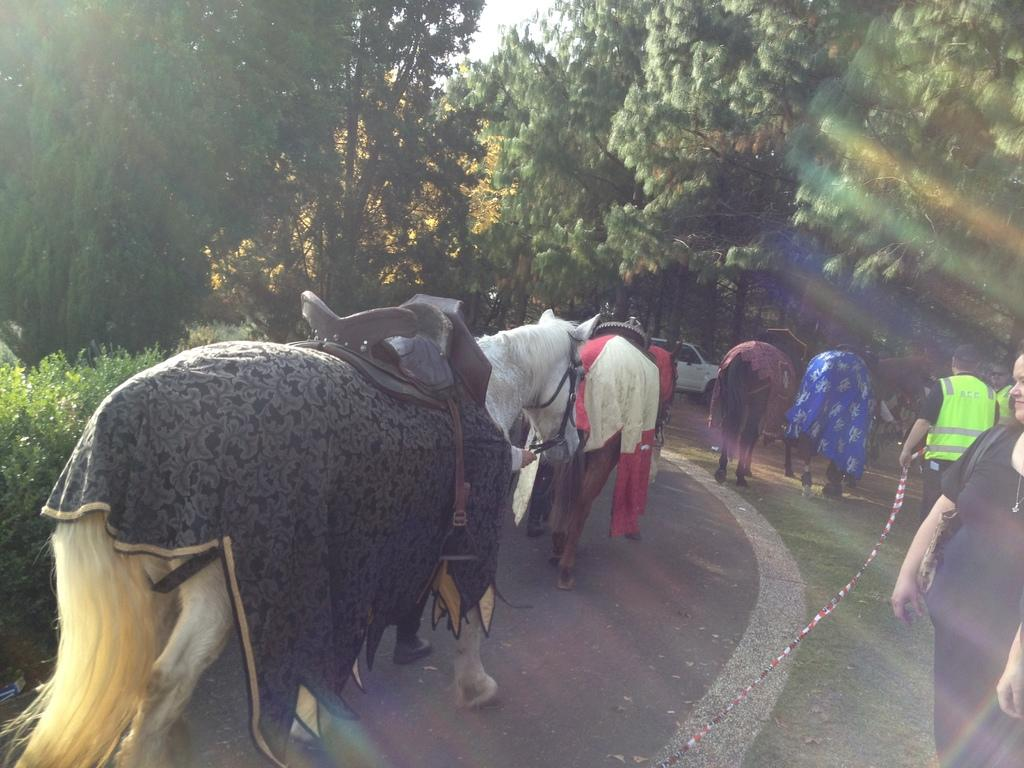How many people are in the image? There are people in the image, but the exact number is not specified. What is the man holding in the image? The man is holding a tape in the image. What animals are present in the image? There are horses in the image. What type of pathway is visible in the image? There is a road in the image. What type of vegetation is present in the image? There are plants in the image. What can be seen in the background of the image? There are trees, a car, and the sky visible in the background of the image. What type of baseball equipment can be seen in the image? There is no baseball equipment present in the image. How many sticks are being used by the people in the image? There is no mention of sticks being used by the people in the image. 